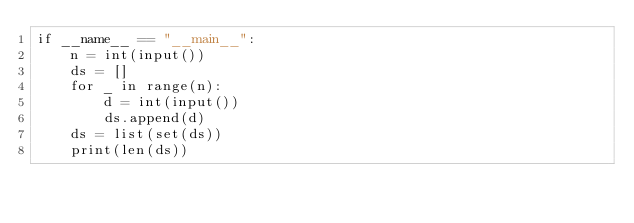<code> <loc_0><loc_0><loc_500><loc_500><_Rust_>if __name__ == "__main__":
    n = int(input())
    ds = []
    for _ in range(n):
        d = int(input())
        ds.append(d)
    ds = list(set(ds))
    print(len(ds))
</code> 